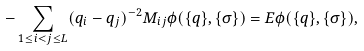Convert formula to latex. <formula><loc_0><loc_0><loc_500><loc_500>- \sum _ { 1 \leq i < j \leq L } ( q _ { i } - q _ { j } ) ^ { - 2 } M _ { i j } \phi ( \{ q \} , \{ \sigma \} ) = E \phi ( \{ q \} , \{ \sigma \} ) ,</formula> 